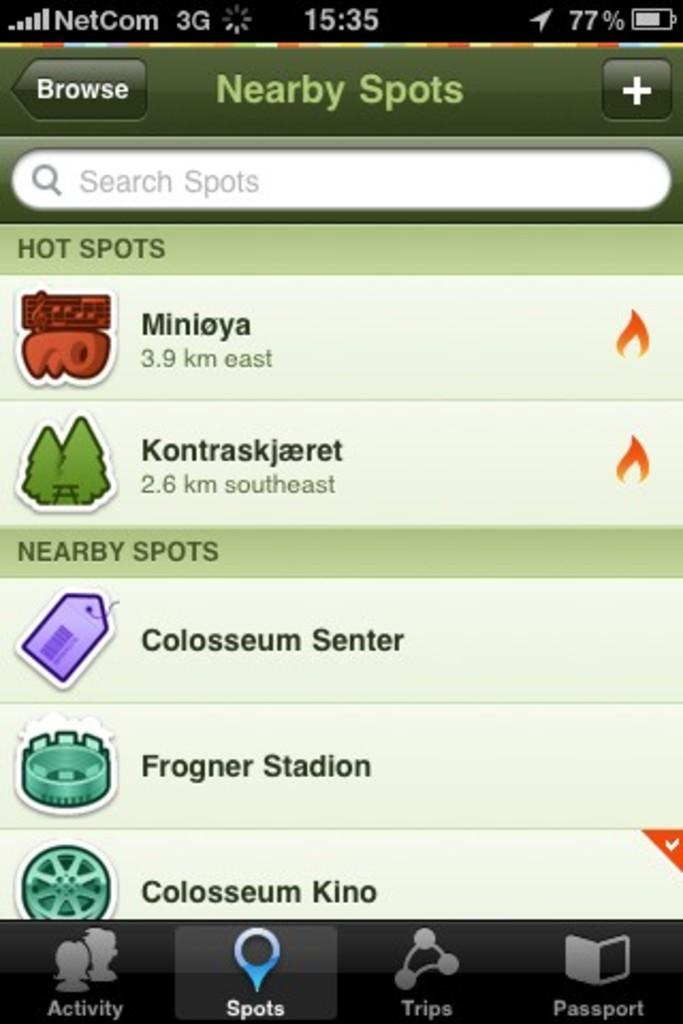<image>
Summarize the visual content of the image. a page on a phone that says Nearby spots on it 